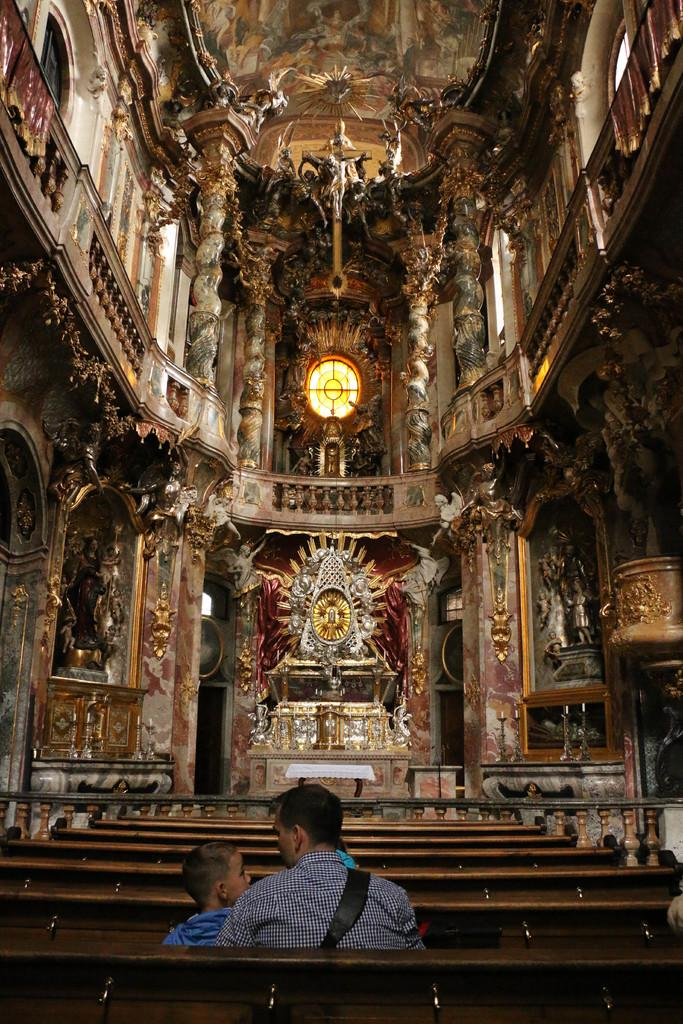What type of location is depicted in the image? The image shows an inside view of a building. What are the people in the image doing? There are persons sitting on a bench in the image. What decorative elements can be seen in the image? There are statues in the image. What architectural features are visible in the image? There are windows and a railing visible in the image. What part of the building's interior can be seen in the image? The ceiling is visible in the image. What type of science experiment is being conducted on the tomatoes in the image? There are no tomatoes or science experiments present in the image. What type of fowl can be seen in the image? There are no birds or fowl present in the image. 